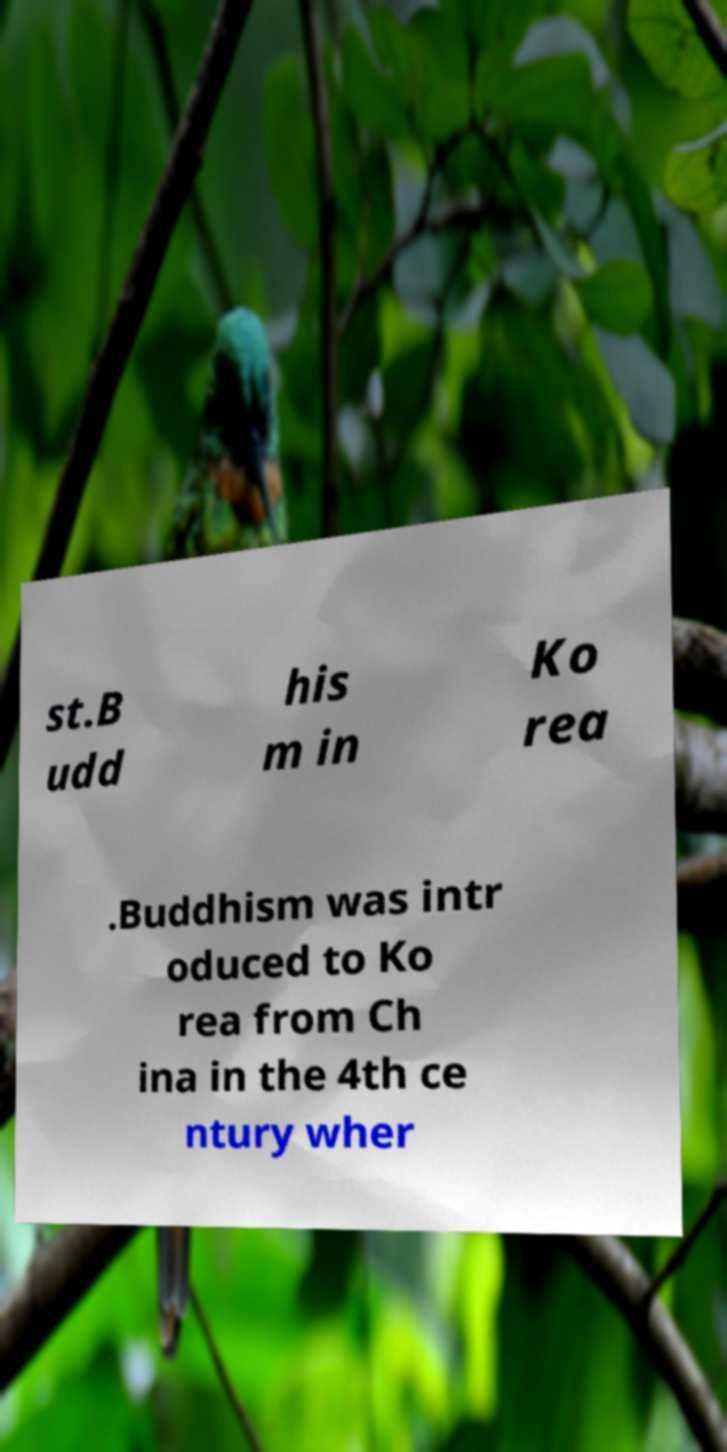Please identify and transcribe the text found in this image. st.B udd his m in Ko rea .Buddhism was intr oduced to Ko rea from Ch ina in the 4th ce ntury wher 